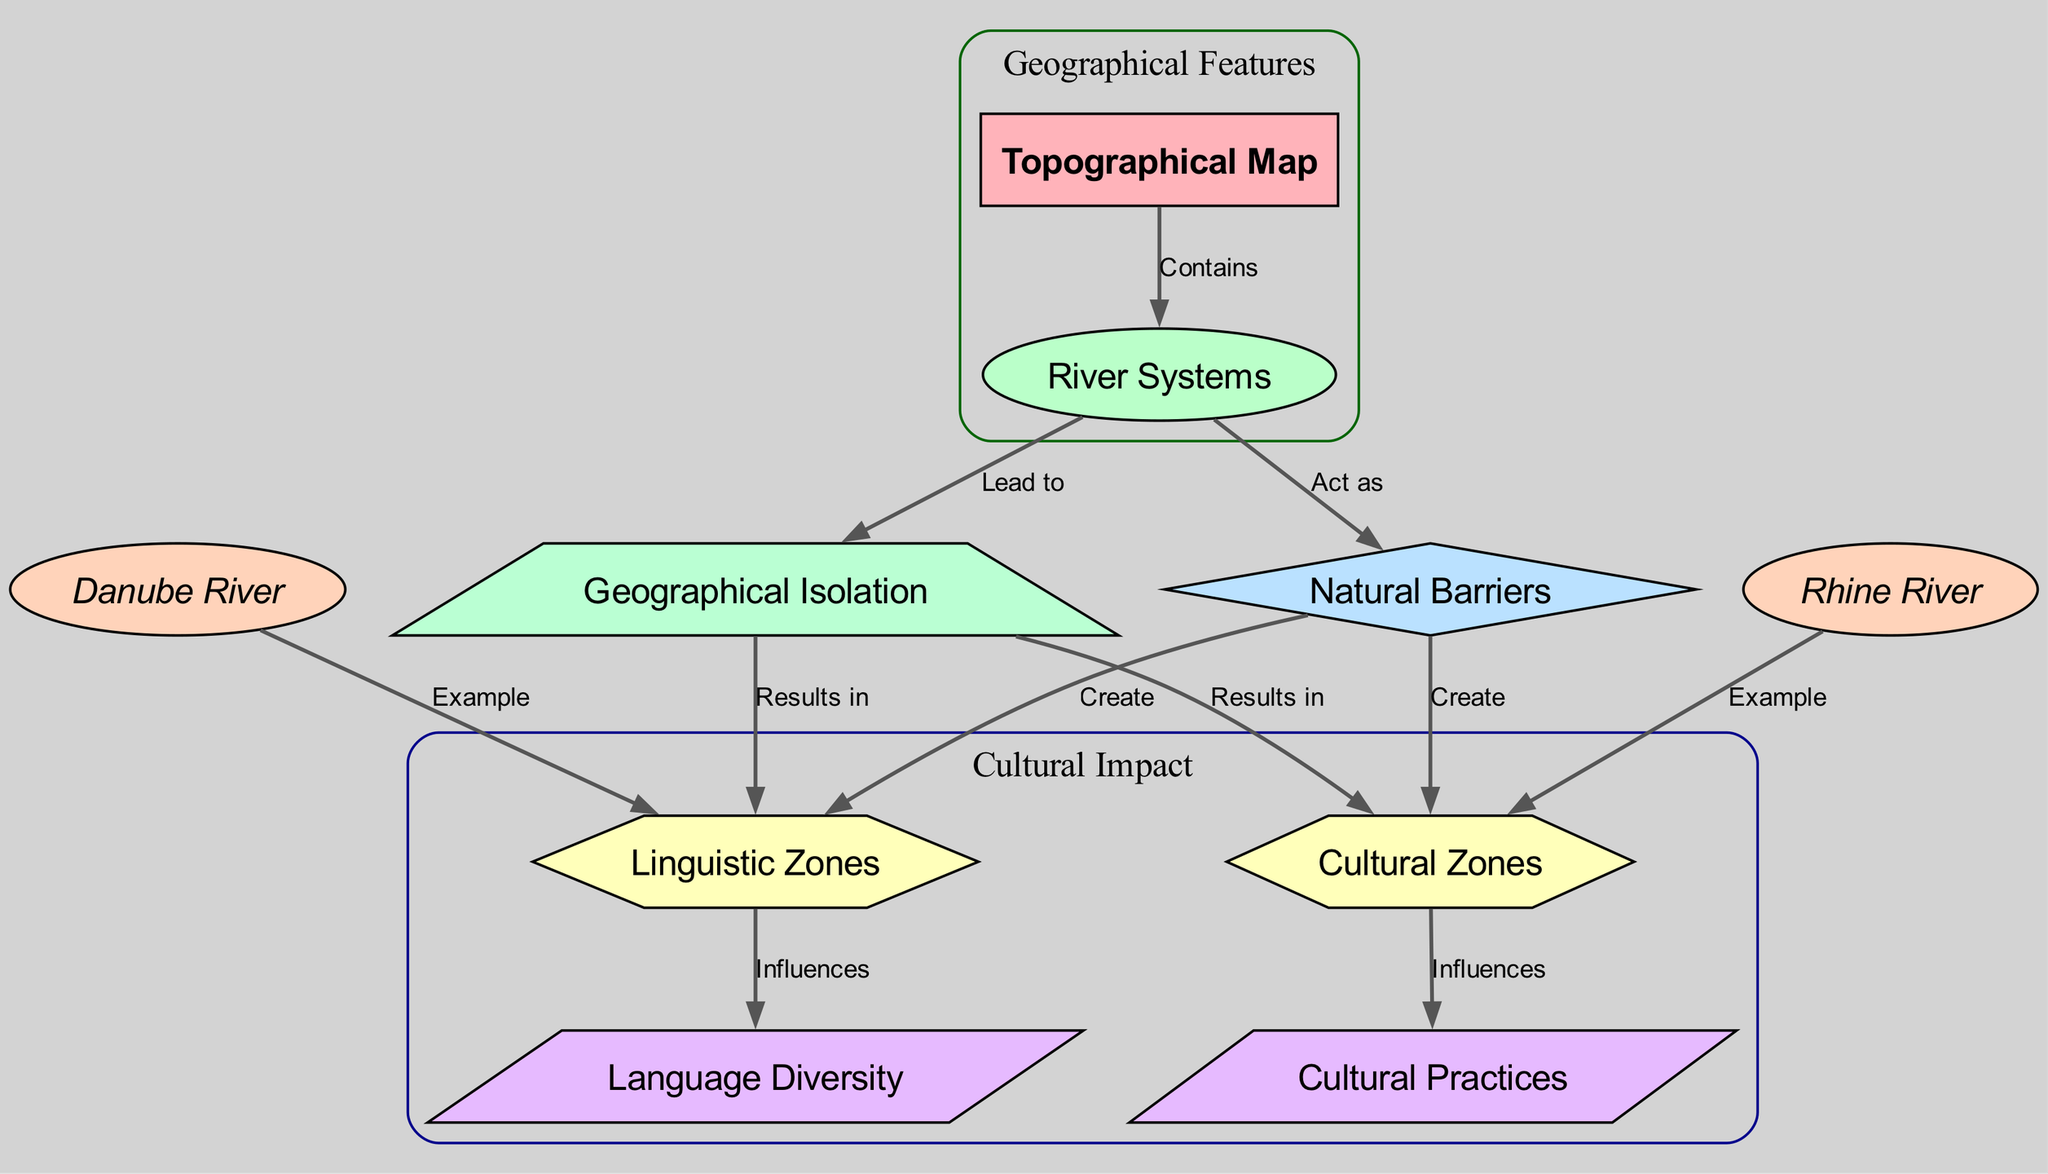What is the main focus of the diagram? The diagram primarily centers on river systems and their influence on cultural identity and linguistic diversity.
Answer: River systems and cultural identity How many types of nodes are present in the diagram? There are seven different types of nodes outlined: main, feature, concept, result, example, effect, and cause.
Answer: Seven What relationship does the Rhine River have in this diagram? The Rhine River is an example that contributes to the creation of cultural zones.
Answer: Example of cultural zones What do natural barriers create according to the diagram? Natural barriers create both linguistic and cultural zones as indicated by the relationships shown.
Answer: Linguistic and cultural zones How does geographical isolation influence linguistic zones? Geographical isolation leads to the formation of distinct linguistic zones due to reduced interaction among different groups.
Answer: Formation of distinct linguistic zones What effect does language diversity have on cultural practices? Language diversity influences cultural practices, indicating a direct relationship between the two aspects.
Answer: Influences How many examples of river systems contributing to cultural zones are presented in the diagram? There are two examples noted in the diagram: the Danube River and the Rhine River.
Answer: Two What is depicted as a result of geographical isolation? Geographical isolation results in the creation of linguistic and cultural zones.
Answer: Creation of linguistic and cultural zones What is the relationship between river systems and natural barriers? River systems act as natural barriers that influence the formation of cultural and linguistic diversity.
Answer: Act as natural barriers 